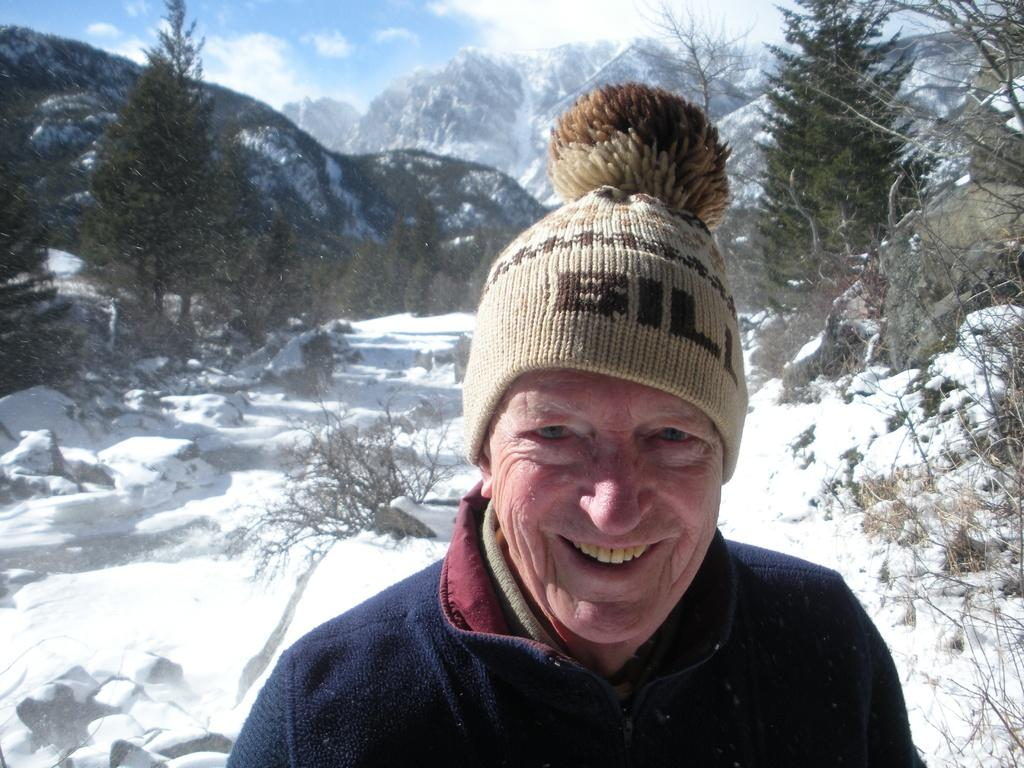What is the main subject of the image? There is a person in the image. What is the person standing on? The person is standing on snow. What is the person doing in the image? The person is taking a picture. Where is the nearest mine to the person in the image? There is no mine present in the image, so it is not possible to determine the nearest mine to the person. 